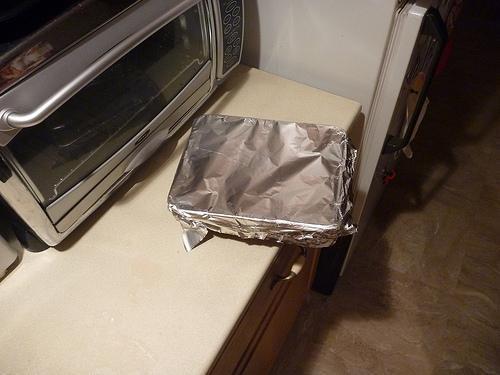How many pans of food are in the photo?
Give a very brief answer. 1. 